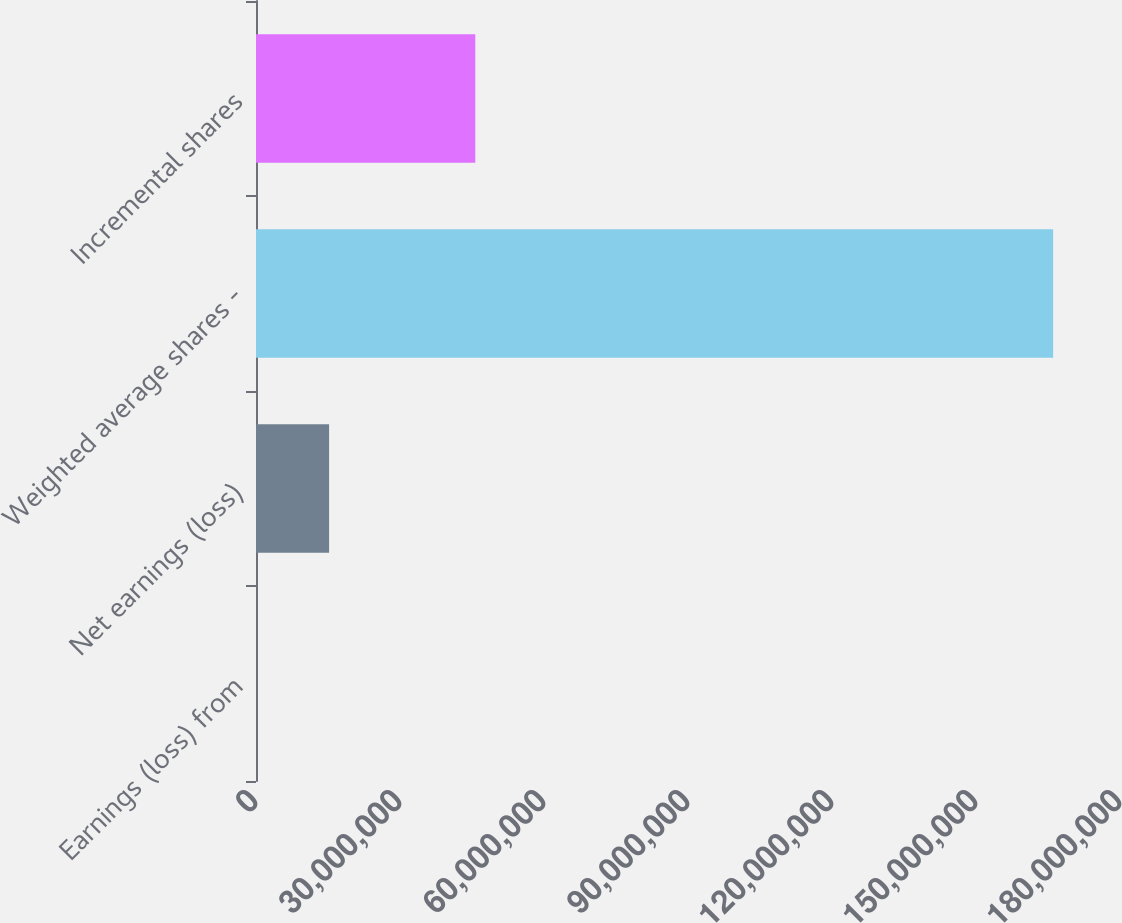Convert chart to OTSL. <chart><loc_0><loc_0><loc_500><loc_500><bar_chart><fcel>Earnings (loss) from<fcel>Net earnings (loss)<fcel>Weighted average shares -<fcel>Incremental shares<nl><fcel>2<fcel>1.52288e+07<fcel>1.66067e+08<fcel>4.56864e+07<nl></chart> 